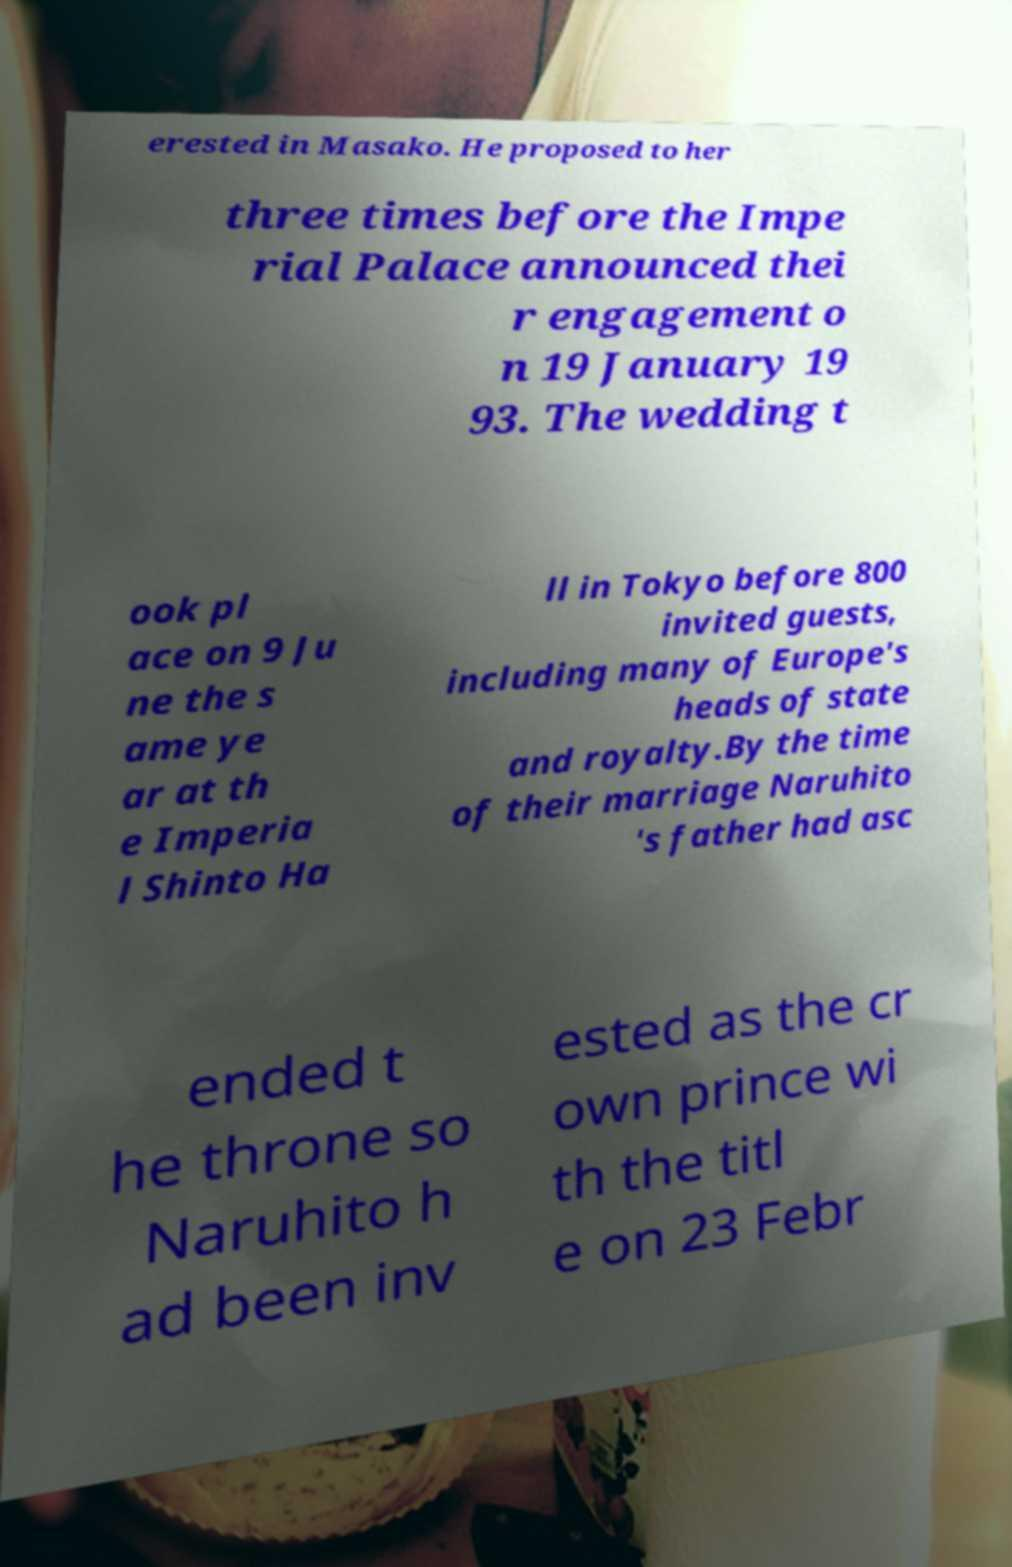Can you accurately transcribe the text from the provided image for me? erested in Masako. He proposed to her three times before the Impe rial Palace announced thei r engagement o n 19 January 19 93. The wedding t ook pl ace on 9 Ju ne the s ame ye ar at th e Imperia l Shinto Ha ll in Tokyo before 800 invited guests, including many of Europe's heads of state and royalty.By the time of their marriage Naruhito 's father had asc ended t he throne so Naruhito h ad been inv ested as the cr own prince wi th the titl e on 23 Febr 